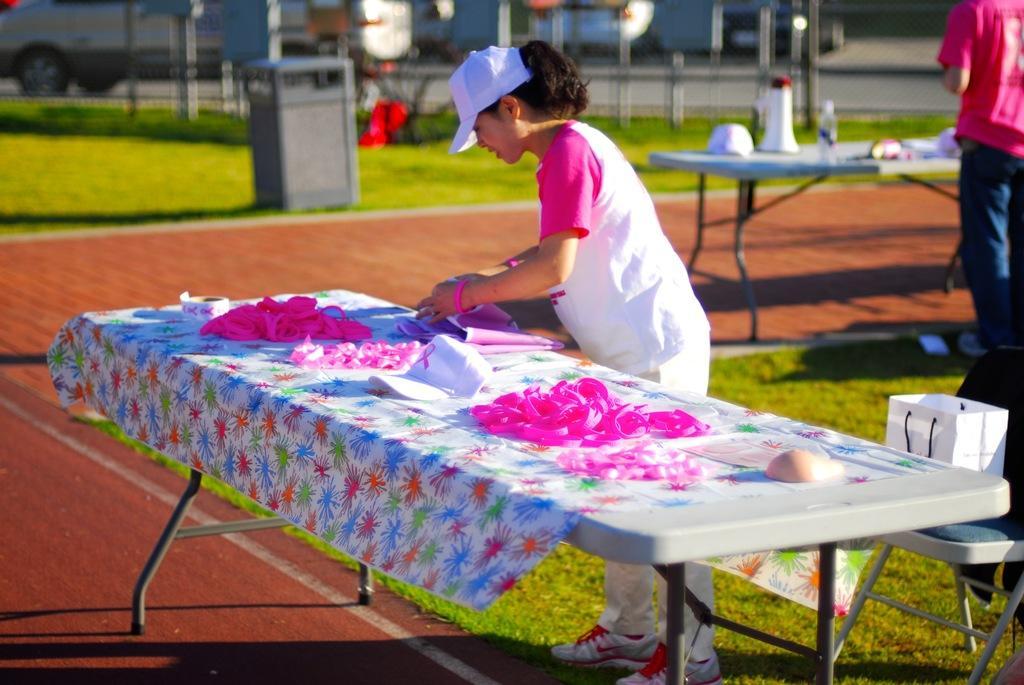How would you summarize this image in a sentence or two? In this image, we can see a few people. We can see the ground with some objects. We can see some grass. There are a few tables with objects. We can see a chair with a paper bag on it. We can also see the fence. We can see a few vehicles. 